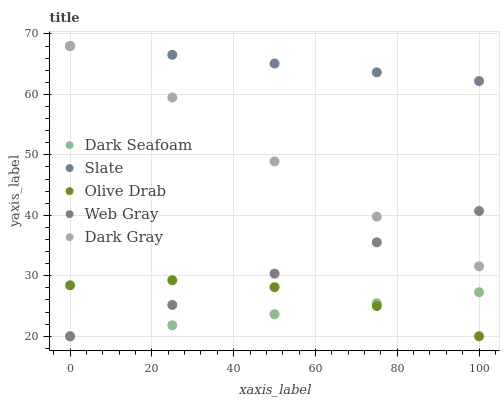Does Dark Seafoam have the minimum area under the curve?
Answer yes or no. Yes. Does Slate have the maximum area under the curve?
Answer yes or no. Yes. Does Web Gray have the minimum area under the curve?
Answer yes or no. No. Does Web Gray have the maximum area under the curve?
Answer yes or no. No. Is Dark Seafoam the smoothest?
Answer yes or no. Yes. Is Olive Drab the roughest?
Answer yes or no. Yes. Is Web Gray the smoothest?
Answer yes or no. No. Is Web Gray the roughest?
Answer yes or no. No. Does Dark Seafoam have the lowest value?
Answer yes or no. Yes. Does Slate have the lowest value?
Answer yes or no. No. Does Slate have the highest value?
Answer yes or no. Yes. Does Web Gray have the highest value?
Answer yes or no. No. Is Olive Drab less than Dark Gray?
Answer yes or no. Yes. Is Slate greater than Dark Seafoam?
Answer yes or no. Yes. Does Olive Drab intersect Web Gray?
Answer yes or no. Yes. Is Olive Drab less than Web Gray?
Answer yes or no. No. Is Olive Drab greater than Web Gray?
Answer yes or no. No. Does Olive Drab intersect Dark Gray?
Answer yes or no. No. 